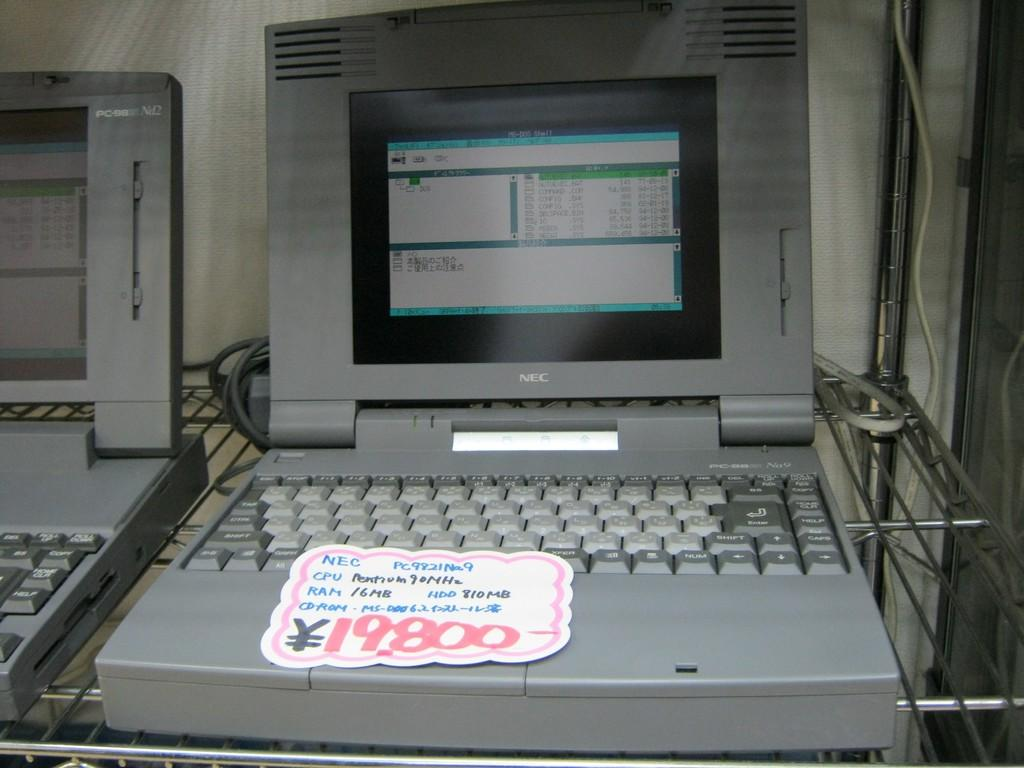<image>
Describe the image concisely. a laptop with a sticker for 19800 on it 